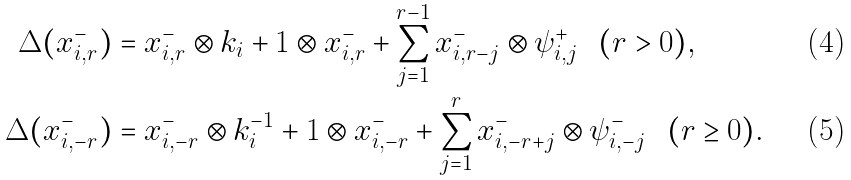<formula> <loc_0><loc_0><loc_500><loc_500>\Delta ( x _ { i , r } ^ { - } ) & = x _ { i , r } ^ { - } \otimes k _ { i } + 1 \otimes x _ { i , r } ^ { - } + \sum _ { j = 1 } ^ { r - 1 } x _ { i , r - j } ^ { - } \otimes \psi ^ { + } _ { i , j } \ \ ( r > 0 ) , \\ \Delta ( x _ { i , - r } ^ { - } ) & = x _ { i , - r } ^ { - } \otimes k _ { i } ^ { - 1 } + 1 \otimes x _ { i , - r } ^ { - } + \sum _ { j = 1 } ^ { r } x _ { i , - r + j } ^ { - } \otimes \psi ^ { - } _ { i , - j } \ \ ( r \geq 0 ) .</formula> 